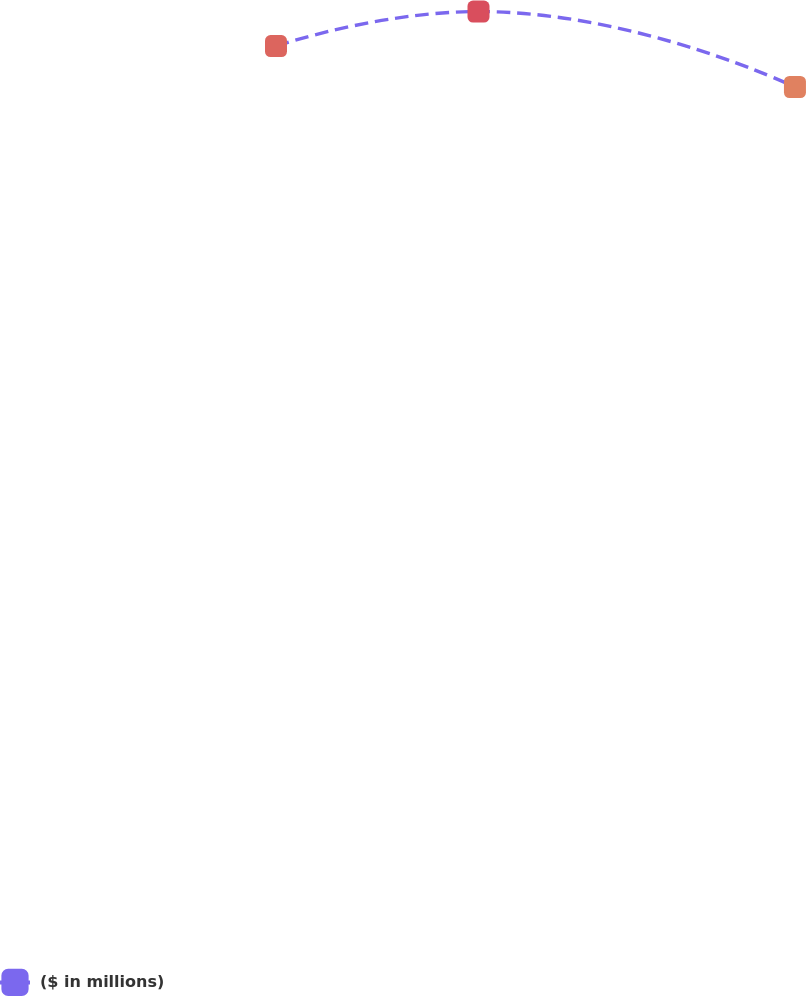Convert chart to OTSL. <chart><loc_0><loc_0><loc_500><loc_500><line_chart><ecel><fcel>($ in millions)<nl><fcel>1651.66<fcel>157.48<nl><fcel>1688.21<fcel>163.96<nl><fcel>1745.33<fcel>149.81<nl><fcel>1861.3<fcel>118.73<nl><fcel>1882.7<fcel>97.08<nl></chart> 